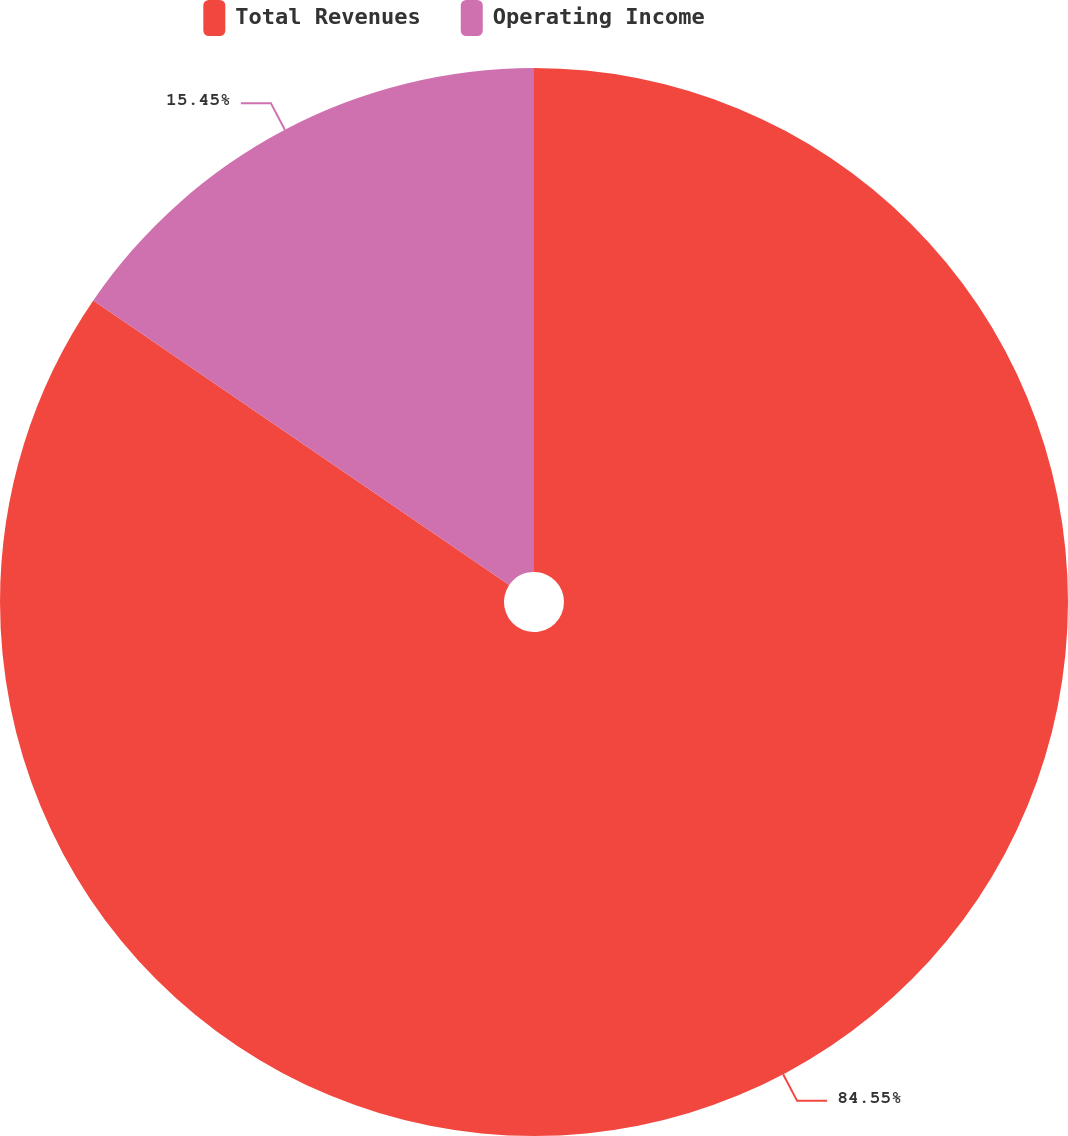Convert chart to OTSL. <chart><loc_0><loc_0><loc_500><loc_500><pie_chart><fcel>Total Revenues<fcel>Operating Income<nl><fcel>84.55%<fcel>15.45%<nl></chart> 